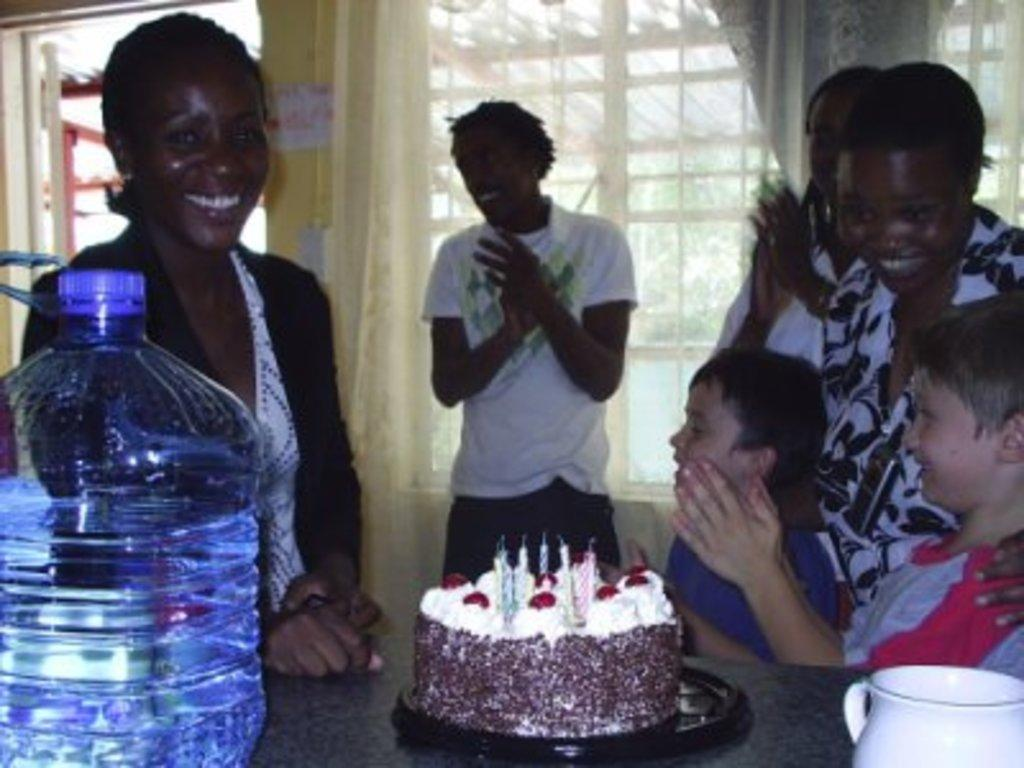How many people are in the image? There are people in the image, but the exact number is not specified. Can you describe the gender of some of the people in the image? Two of the people in the image are boys. What type of beverage container is present in the image? There is a water bottle in the image. What type of food item is present in the image? There is a cake in the image. What type of drinking vessel is present in the image? There is a cup in the image. What type of paste is being used to perform magic tricks in the image? There is no paste or magic tricks present in the image. 